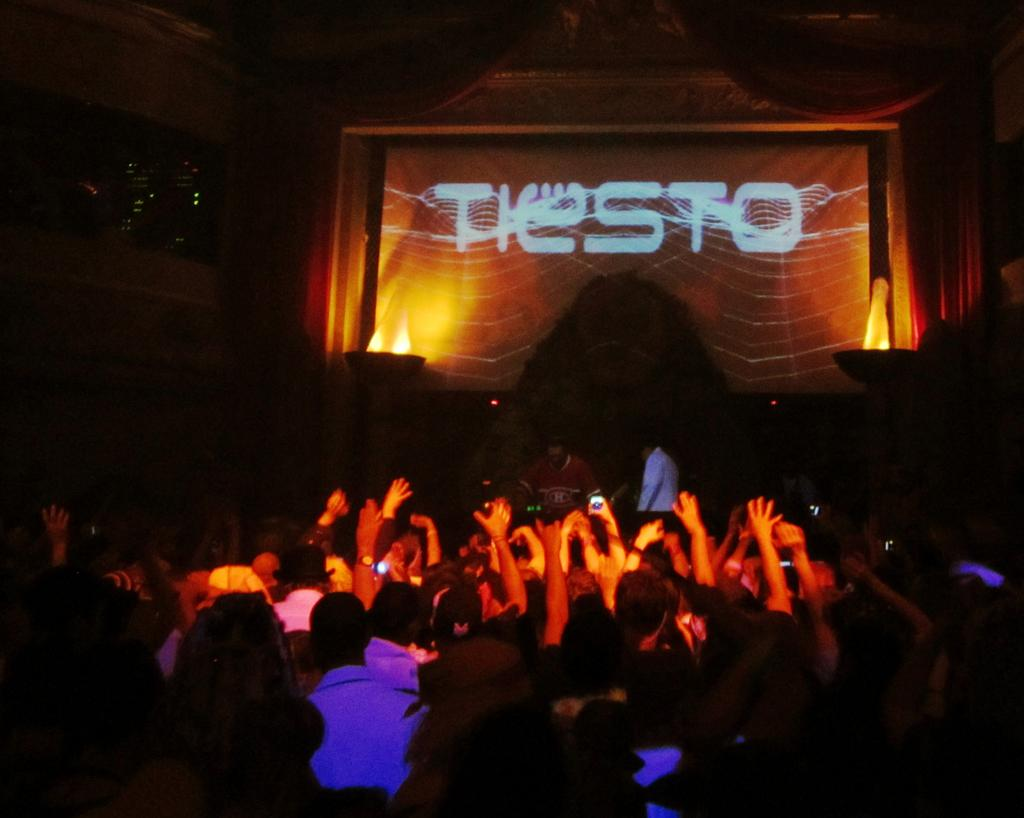What is the main subject of the image? The main subject of the image is a crowd. What can be seen in the background of the image? In the background of the image, there are lights, a screen, and curtains. What are some people in the crowd doing? Some people in the crowd are holding mobiles. What type of news can be heard coming from the mine in the image? There is no mine present in the image, and therefore no news can be heard coming from it. 